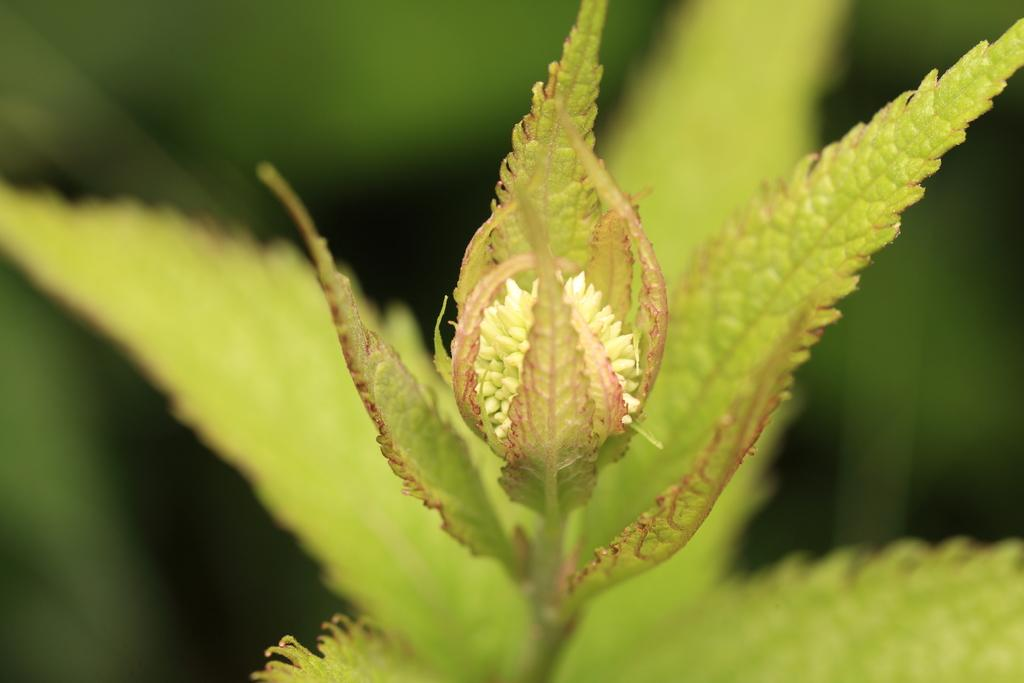What is the main subject of the image? The main subject of the image is a bud. What else can be seen in the image besides the bud? There are leaves in the image. How would you describe the background of the image? The background of the image is blurred. Are there any leaves in the background of the image? Yes, leaves are present in the background of the image. What type of beam is holding up the bud in the image? There is no beam present in the image; the bud is not being held up by any visible support. 